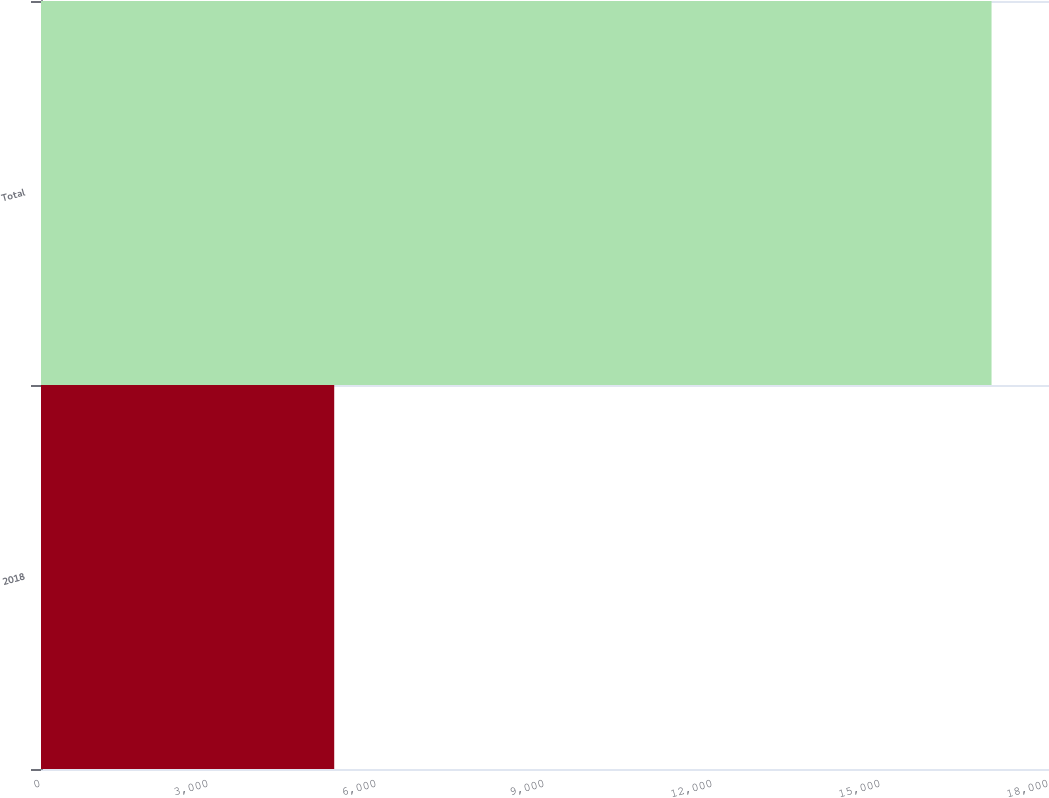<chart> <loc_0><loc_0><loc_500><loc_500><bar_chart><fcel>2018<fcel>Total<nl><fcel>5236<fcel>16974<nl></chart> 